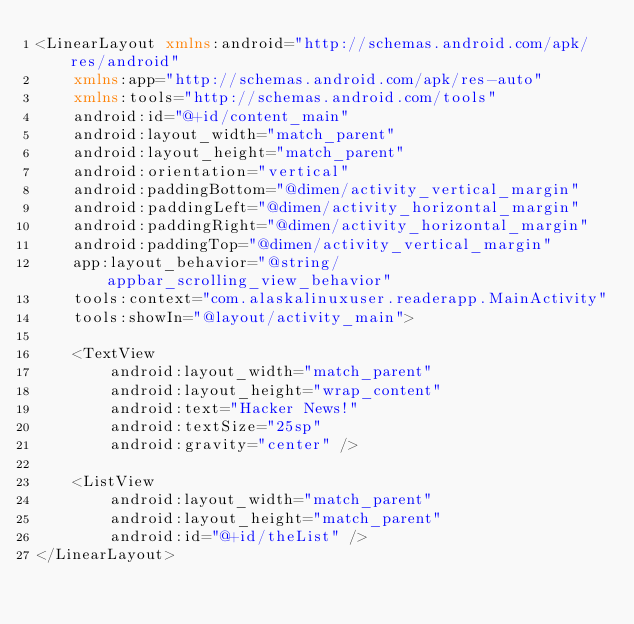<code> <loc_0><loc_0><loc_500><loc_500><_XML_><LinearLayout xmlns:android="http://schemas.android.com/apk/res/android"
    xmlns:app="http://schemas.android.com/apk/res-auto"
    xmlns:tools="http://schemas.android.com/tools"
    android:id="@+id/content_main"
    android:layout_width="match_parent"
    android:layout_height="match_parent"
    android:orientation="vertical"
    android:paddingBottom="@dimen/activity_vertical_margin"
    android:paddingLeft="@dimen/activity_horizontal_margin"
    android:paddingRight="@dimen/activity_horizontal_margin"
    android:paddingTop="@dimen/activity_vertical_margin"
    app:layout_behavior="@string/appbar_scrolling_view_behavior"
    tools:context="com.alaskalinuxuser.readerapp.MainActivity"
    tools:showIn="@layout/activity_main">

    <TextView
        android:layout_width="match_parent"
        android:layout_height="wrap_content"
        android:text="Hacker News!"
        android:textSize="25sp"
        android:gravity="center" />

    <ListView
        android:layout_width="match_parent"
        android:layout_height="match_parent"
        android:id="@+id/theList" />
</LinearLayout>
</code> 